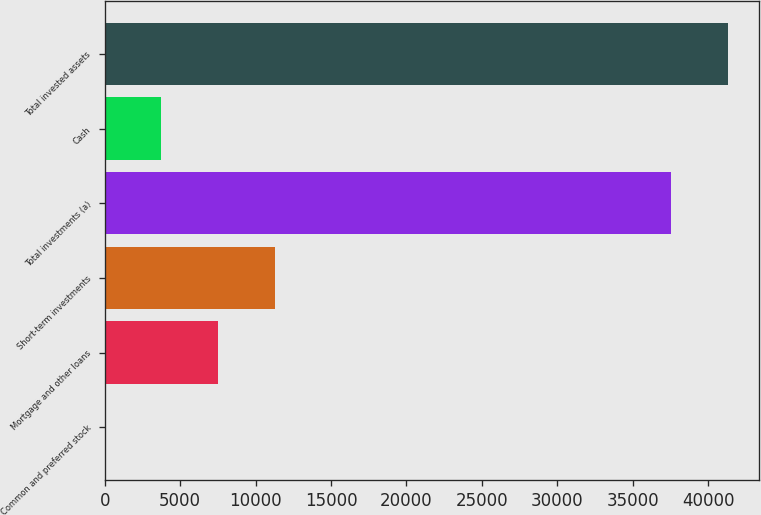Convert chart. <chart><loc_0><loc_0><loc_500><loc_500><bar_chart><fcel>Common and preferred stock<fcel>Mortgage and other loans<fcel>Short-term investments<fcel>Total investments (a)<fcel>Cash<fcel>Total invested assets<nl><fcel>1<fcel>7521.8<fcel>11282.2<fcel>37540<fcel>3761.4<fcel>41300.4<nl></chart> 